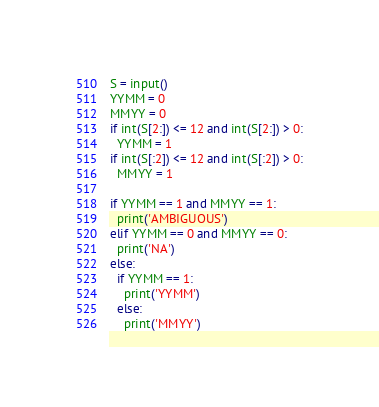Convert code to text. <code><loc_0><loc_0><loc_500><loc_500><_Python_>S = input()
YYMM = 0
MMYY = 0
if int(S[2:]) <= 12 and int(S[2:]) > 0:
  YYMM = 1
if int(S[:2]) <= 12 and int(S[:2]) > 0:
  MMYY = 1
  
if YYMM == 1 and MMYY == 1:
  print('AMBIGUOUS')
elif YYMM == 0 and MMYY == 0:
  print('NA')
else:
  if YYMM == 1:
    print('YYMM')
  else:
    print('MMYY')</code> 